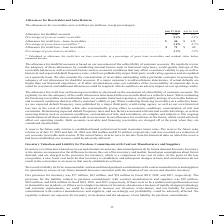According to Cisco Systems's financial document, How was the percentage of gross lease receivables calculated? as allowance for credit loss on lease receivables as a percentage of gross lease receivables and residual value before unearned income. The document states: "(1) Calculated as allowance for credit loss on lease receivables as a percentage of gross lease receivables and residual value before unearned income...." Also, What is the allowance for doubtful accounts based on? our assessment of the collectibility of customer accounts. The document states: "The allowance for doubtful accounts is based on our assessment of the collectibility of customer accounts. We regularly review the adequacy of these a..." Also, What was the Percentage of gross loan receivables in 2019? According to the financial document, 1.3 (percentage). The relevant text states: "$ 71 $ 60 Percentage of gross loan receivables . 1.3% 1.2%..." Also, can you calculate: What would be the change in Allowance for credit loss—loan receivables between 2018 and 2019? Based on the calculation: 71-60, the result is 11 (in millions). This is based on the information: "7% Allowance for credit loss—loan receivables . $ 71 $ 60 Percentage of gross loan receivables . 1.3% 1.2% lowance for credit loss—loan receivables . $ 71 $ 60 Percentage of gross loan receivables . 1..." The key data points involved are: 60, 71. Also, How many years did Percentage of gross lease receivables exceed 2.0%? Based on the analysis, there are 1 instances. The counting process: 2018. Also, can you calculate: What was the percentage change in Allowance for doubtful accounts between 2018 and 2019? To answer this question, I need to perform calculations using the financial data. The calculation is: (136-129)/129, which equals 5.43 (percentage). This is based on the information: "July 28, 2018 Allowance for doubtful accounts . $ 136 $ 129 Percentage of gross accounts receivable . 2.4% 2.3% Allowance for credit loss—lease receivabl 8, 2018 Allowance for doubtful accounts . $ 13..." The key data points involved are: 129, 136. 